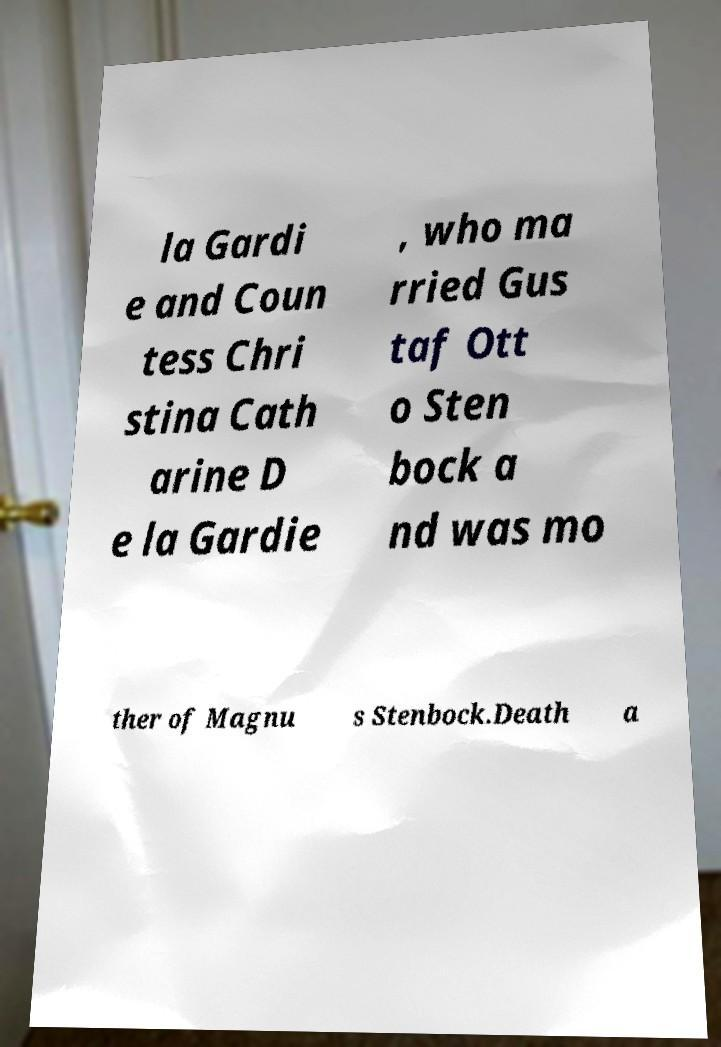Can you read and provide the text displayed in the image?This photo seems to have some interesting text. Can you extract and type it out for me? la Gardi e and Coun tess Chri stina Cath arine D e la Gardie , who ma rried Gus taf Ott o Sten bock a nd was mo ther of Magnu s Stenbock.Death a 